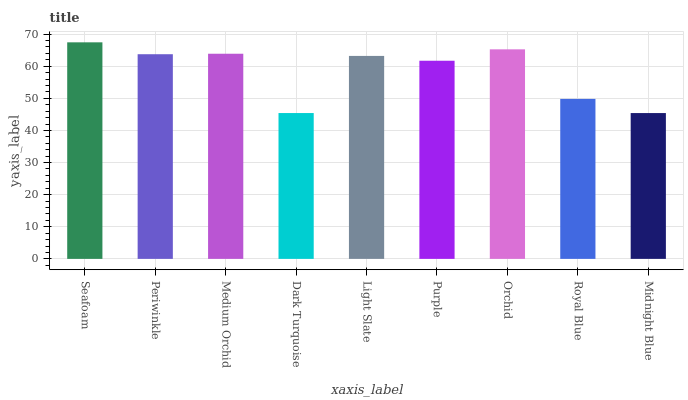Is Midnight Blue the minimum?
Answer yes or no. Yes. Is Seafoam the maximum?
Answer yes or no. Yes. Is Periwinkle the minimum?
Answer yes or no. No. Is Periwinkle the maximum?
Answer yes or no. No. Is Seafoam greater than Periwinkle?
Answer yes or no. Yes. Is Periwinkle less than Seafoam?
Answer yes or no. Yes. Is Periwinkle greater than Seafoam?
Answer yes or no. No. Is Seafoam less than Periwinkle?
Answer yes or no. No. Is Light Slate the high median?
Answer yes or no. Yes. Is Light Slate the low median?
Answer yes or no. Yes. Is Orchid the high median?
Answer yes or no. No. Is Dark Turquoise the low median?
Answer yes or no. No. 